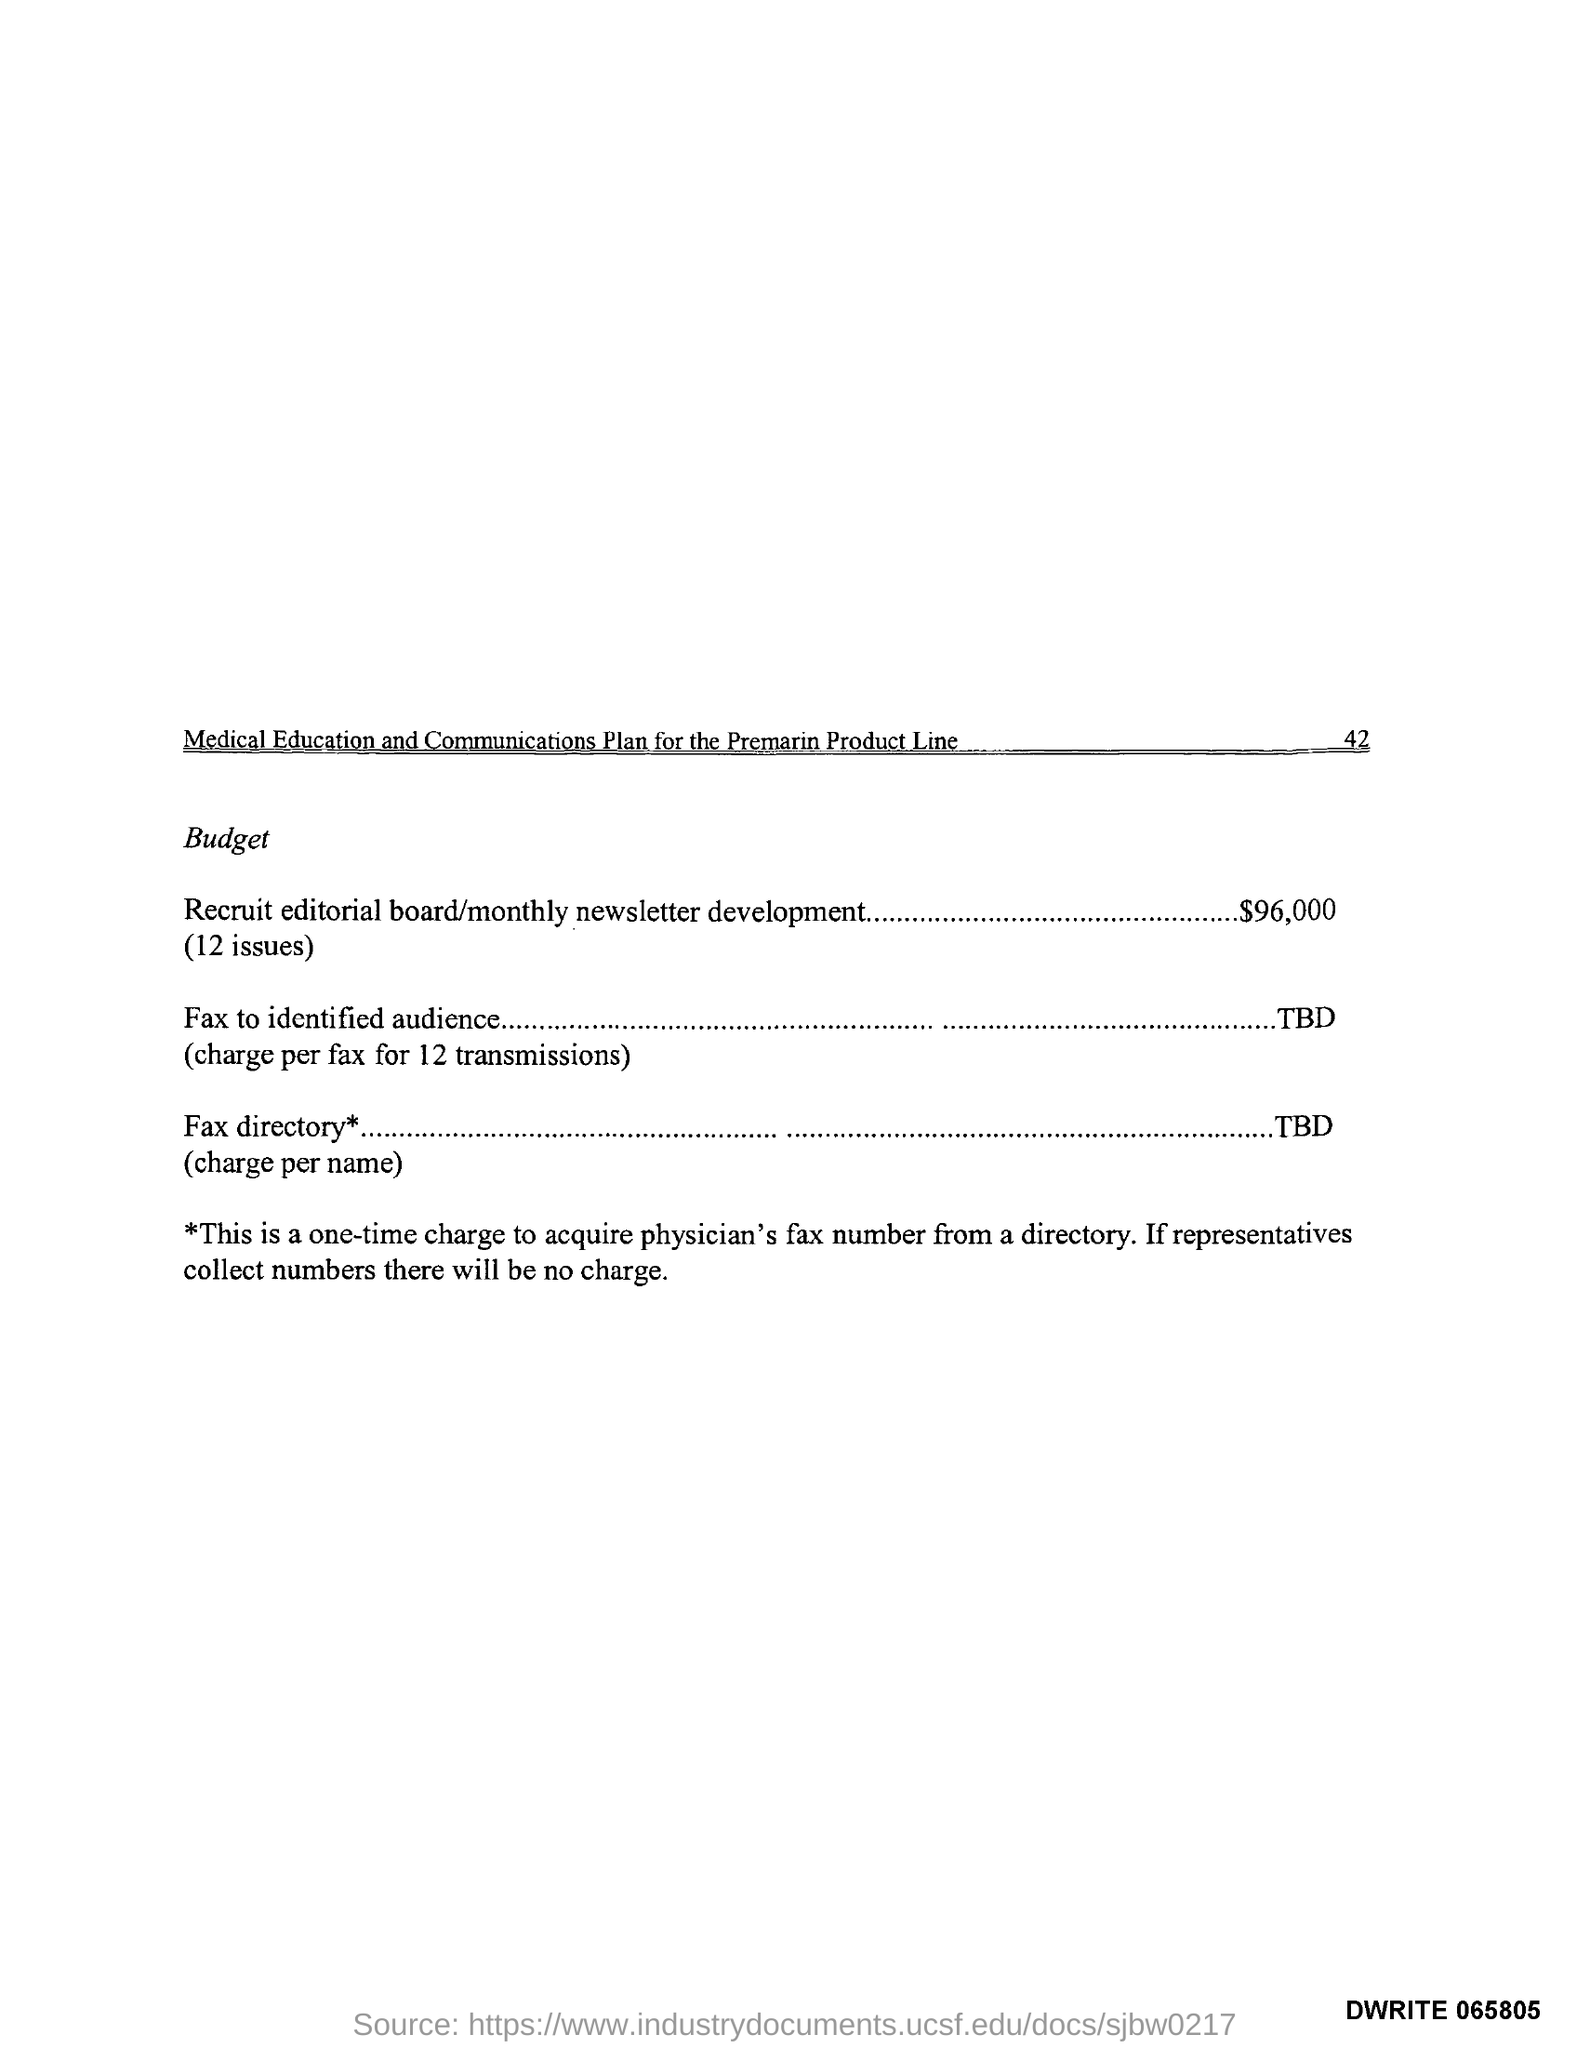What is the page number of "medical education and communication plan for the premarian product line"?
Your response must be concise. 42. 